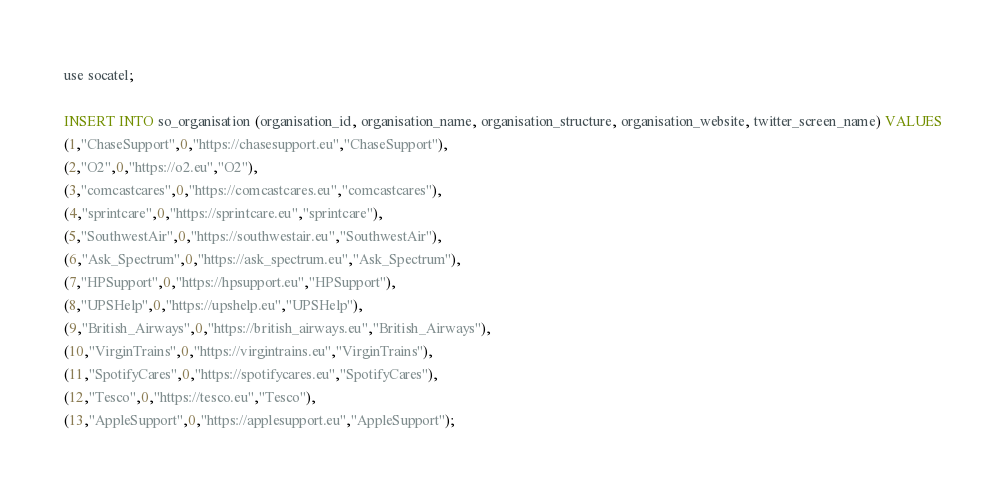Convert code to text. <code><loc_0><loc_0><loc_500><loc_500><_SQL_>use socatel;

INSERT INTO so_organisation (organisation_id, organisation_name, organisation_structure, organisation_website, twitter_screen_name) VALUES
(1,"ChaseSupport",0,"https://chasesupport.eu","ChaseSupport"),
(2,"O2",0,"https://o2.eu","O2"),
(3,"comcastcares",0,"https://comcastcares.eu","comcastcares"),
(4,"sprintcare",0,"https://sprintcare.eu","sprintcare"),
(5,"SouthwestAir",0,"https://southwestair.eu","SouthwestAir"),
(6,"Ask_Spectrum",0,"https://ask_spectrum.eu","Ask_Spectrum"),
(7,"HPSupport",0,"https://hpsupport.eu","HPSupport"),
(8,"UPSHelp",0,"https://upshelp.eu","UPSHelp"),
(9,"British_Airways",0,"https://british_airways.eu","British_Airways"),
(10,"VirginTrains",0,"https://virgintrains.eu","VirginTrains"),
(11,"SpotifyCares",0,"https://spotifycares.eu","SpotifyCares"),
(12,"Tesco",0,"https://tesco.eu","Tesco"),
(13,"AppleSupport",0,"https://applesupport.eu","AppleSupport");</code> 